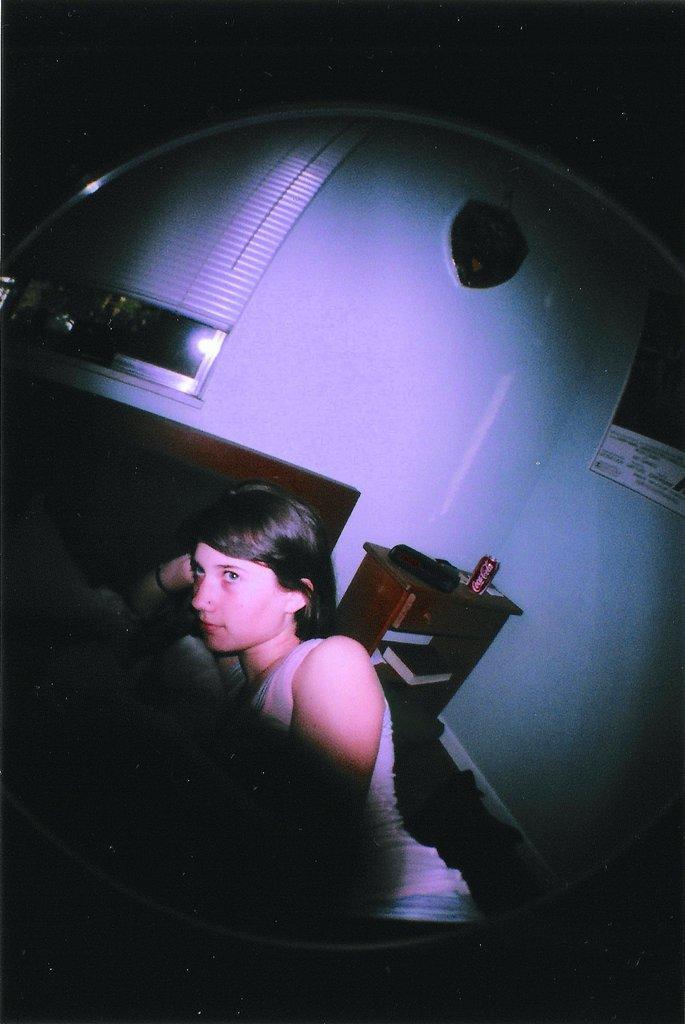Describe this image in one or two sentences. Here I can see a woman laying on a bed. Beside the bed there is a table on which a cock-tin and some other objects are placed and also there are few books. In the background there is a wall on which a poster is attached and also there is a window. The background is in black color. 